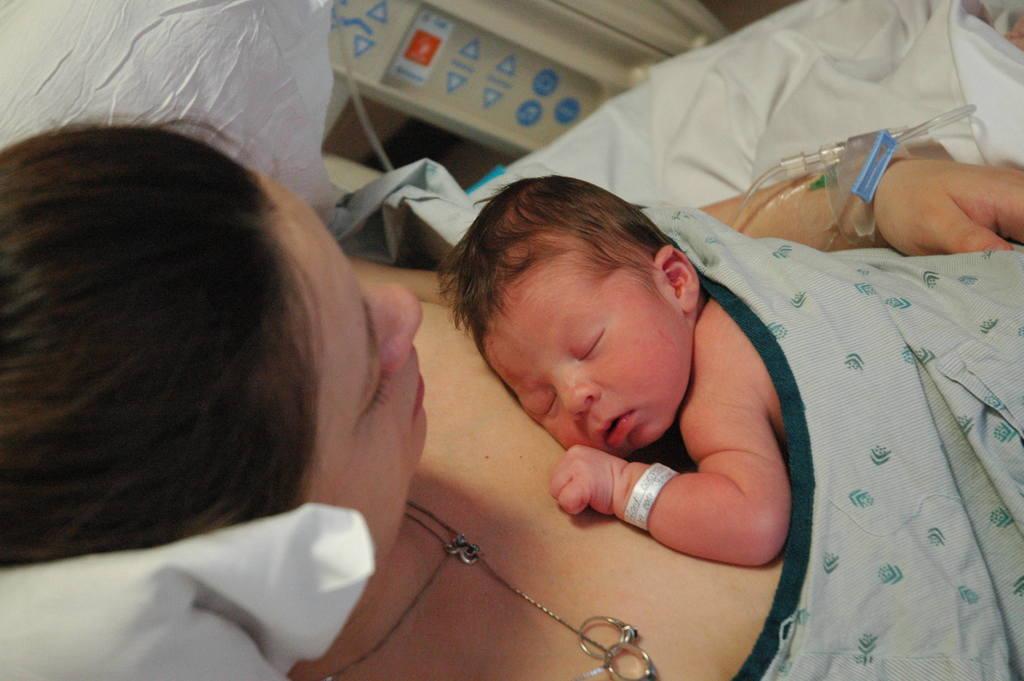How would you summarize this image in a sentence or two? In this image we can see a kid lying on a woman. Here we can see a pillow, clothes, rings, chain, and other objects. 